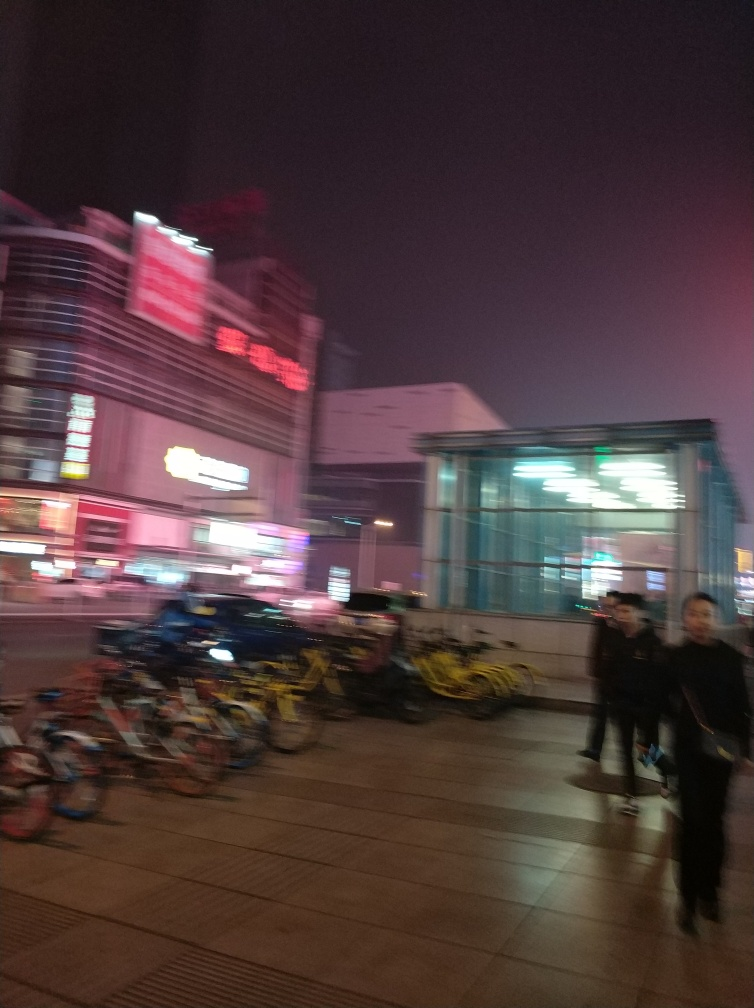Are there any identifiable landmarks or businesses in this photo? It is difficult to clearly identify specific landmarks or businesses due to the photo's blurriness. However, the glowing signs suggest it's a commercial area with multiple shops or establishments. 